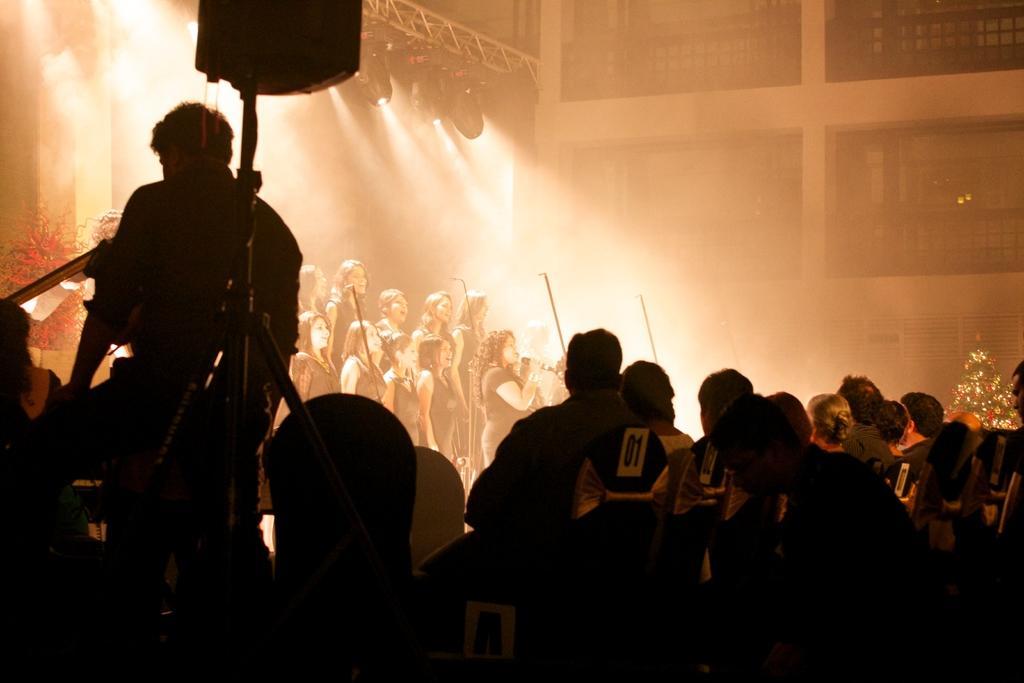Describe this image in one or two sentences. In this image I can see there are group of persons standing and sum of them are playing a music ,at the top I can see focus of light and the wall 